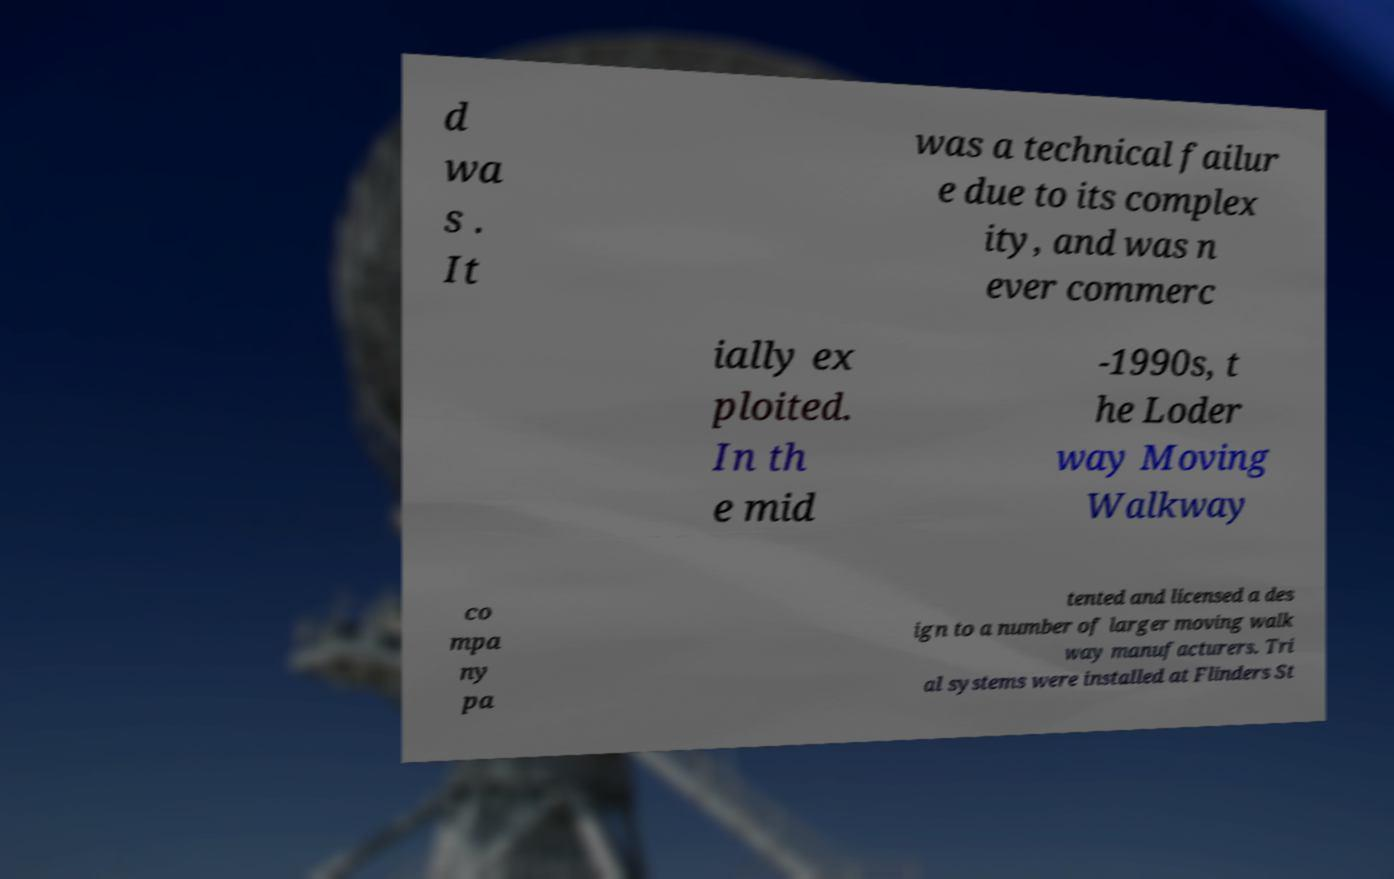Could you extract and type out the text from this image? d wa s . It was a technical failur e due to its complex ity, and was n ever commerc ially ex ploited. In th e mid -1990s, t he Loder way Moving Walkway co mpa ny pa tented and licensed a des ign to a number of larger moving walk way manufacturers. Tri al systems were installed at Flinders St 